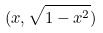Convert formula to latex. <formula><loc_0><loc_0><loc_500><loc_500>( x , \sqrt { 1 - x ^ { 2 } } )</formula> 